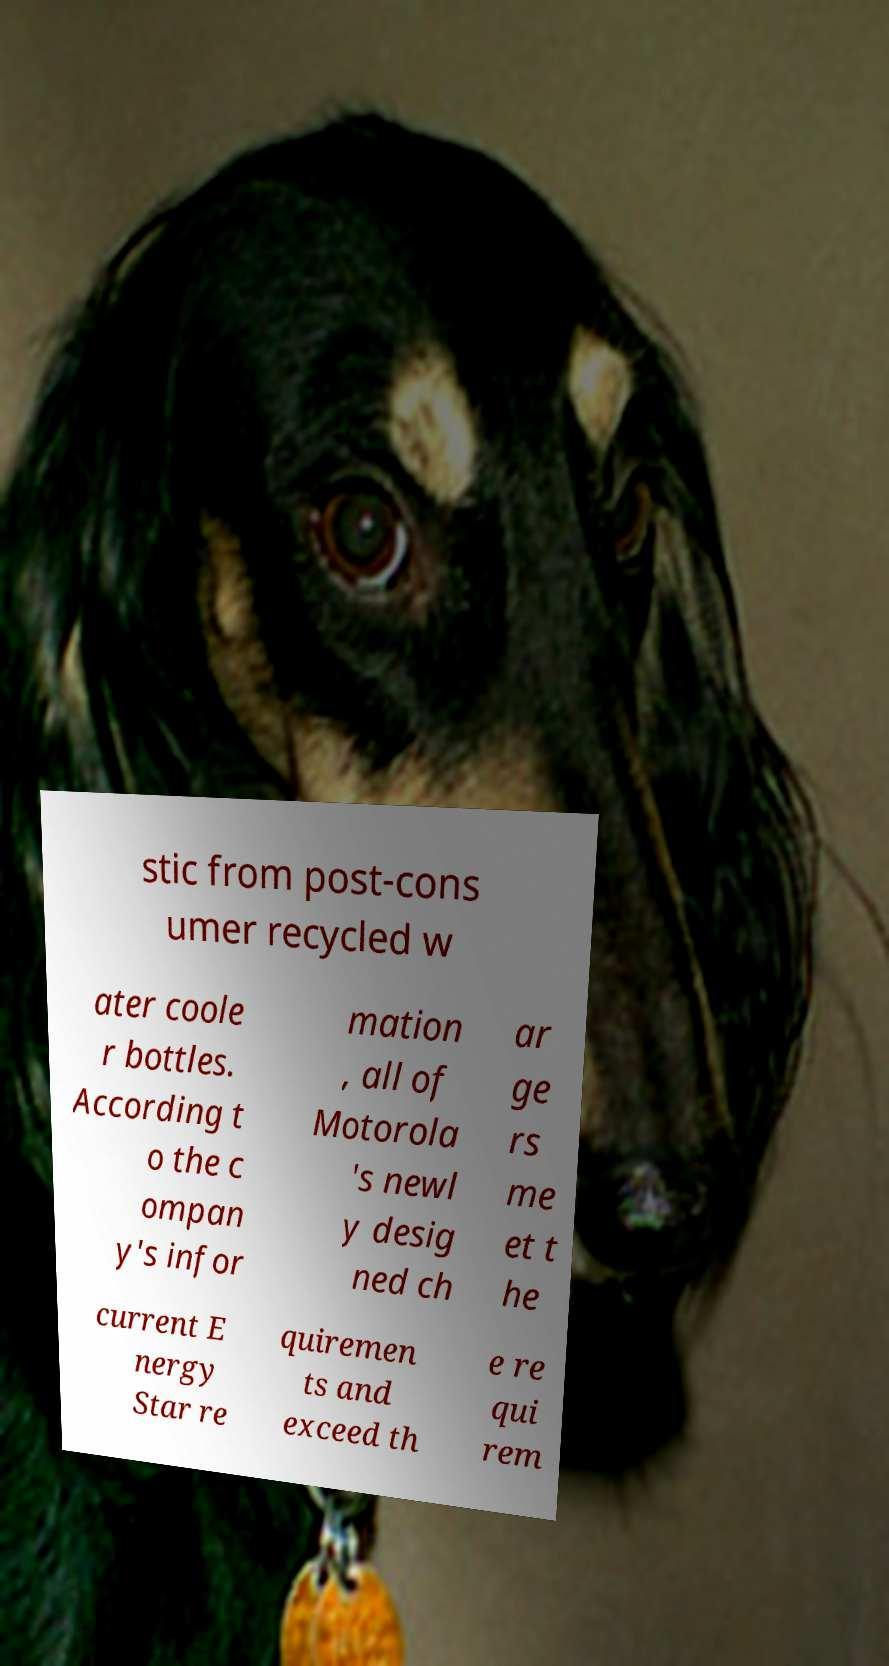Can you read and provide the text displayed in the image?This photo seems to have some interesting text. Can you extract and type it out for me? stic from post-cons umer recycled w ater coole r bottles. According t o the c ompan y's infor mation , all of Motorola 's newl y desig ned ch ar ge rs me et t he current E nergy Star re quiremen ts and exceed th e re qui rem 